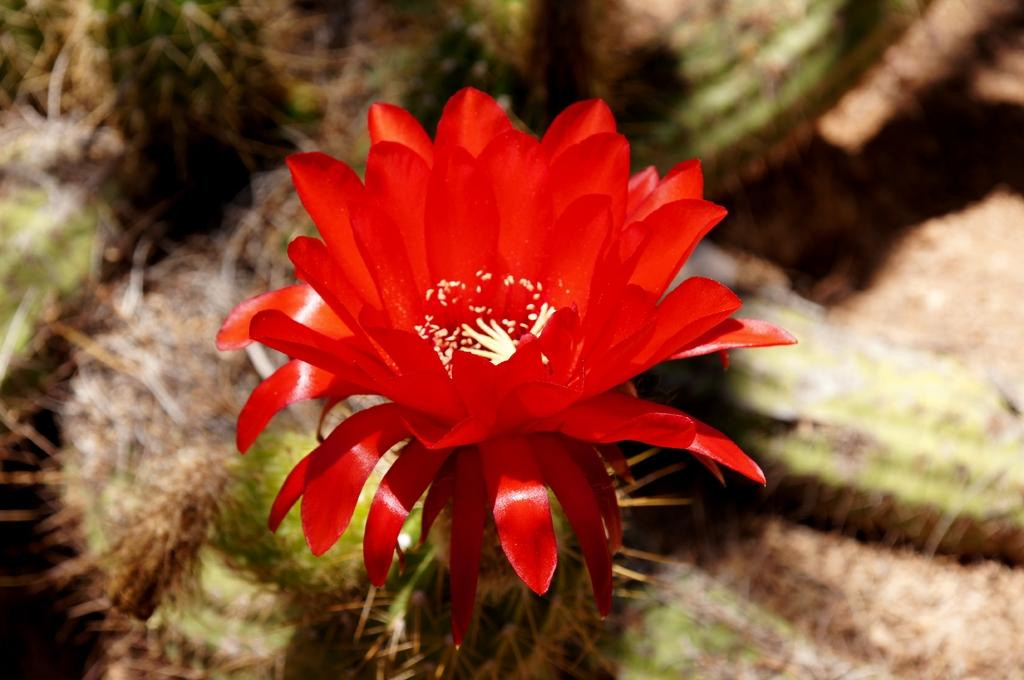What type of flower is in the image? There is a red color flower in the image. Can you describe the background of the image? The background of the image is blurred. What type of instrument is being played by the frogs on the road in the image? There are no frogs or instruments present in the image, nor is there a road. 